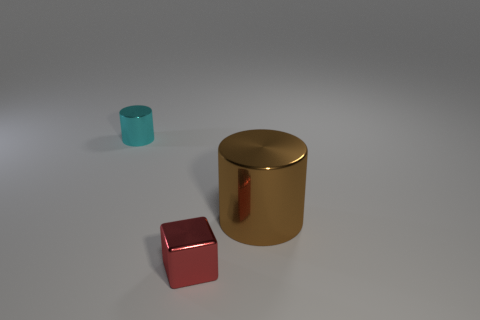Are there fewer red metal things right of the small red object than tiny cyan metallic things on the left side of the big thing?
Make the answer very short. Yes. Does the cyan shiny cylinder have the same size as the shiny cylinder that is in front of the tiny cylinder?
Make the answer very short. No. The object that is behind the tiny block and in front of the cyan thing has what shape?
Offer a terse response. Cylinder. There is a cyan cylinder that is made of the same material as the tiny block; what size is it?
Offer a very short reply. Small. What number of small cyan cylinders are left of the metallic cylinder on the right side of the red shiny block?
Ensure brevity in your answer.  1. Are the object that is in front of the big brown thing and the small cyan cylinder made of the same material?
Provide a succinct answer. Yes. How big is the shiny object that is in front of the object that is on the right side of the tiny red metallic object?
Offer a very short reply. Small. How big is the object that is on the left side of the small shiny thing in front of the metal cylinder that is on the right side of the cyan metallic cylinder?
Offer a very short reply. Small. There is a thing left of the red object; is its shape the same as the tiny metal object in front of the small cyan shiny thing?
Ensure brevity in your answer.  No. How many other objects are there of the same color as the large object?
Your answer should be very brief. 0. 